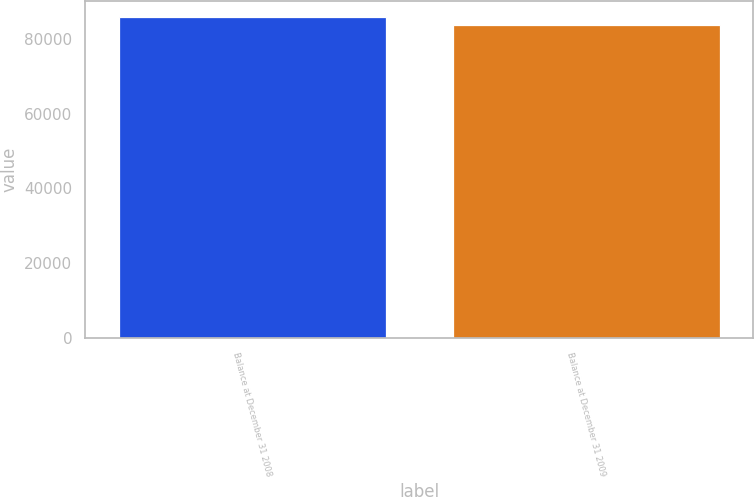Convert chart to OTSL. <chart><loc_0><loc_0><loc_500><loc_500><bar_chart><fcel>Balance at December 31 2008<fcel>Balance at December 31 2009<nl><fcel>85875<fcel>83875<nl></chart> 